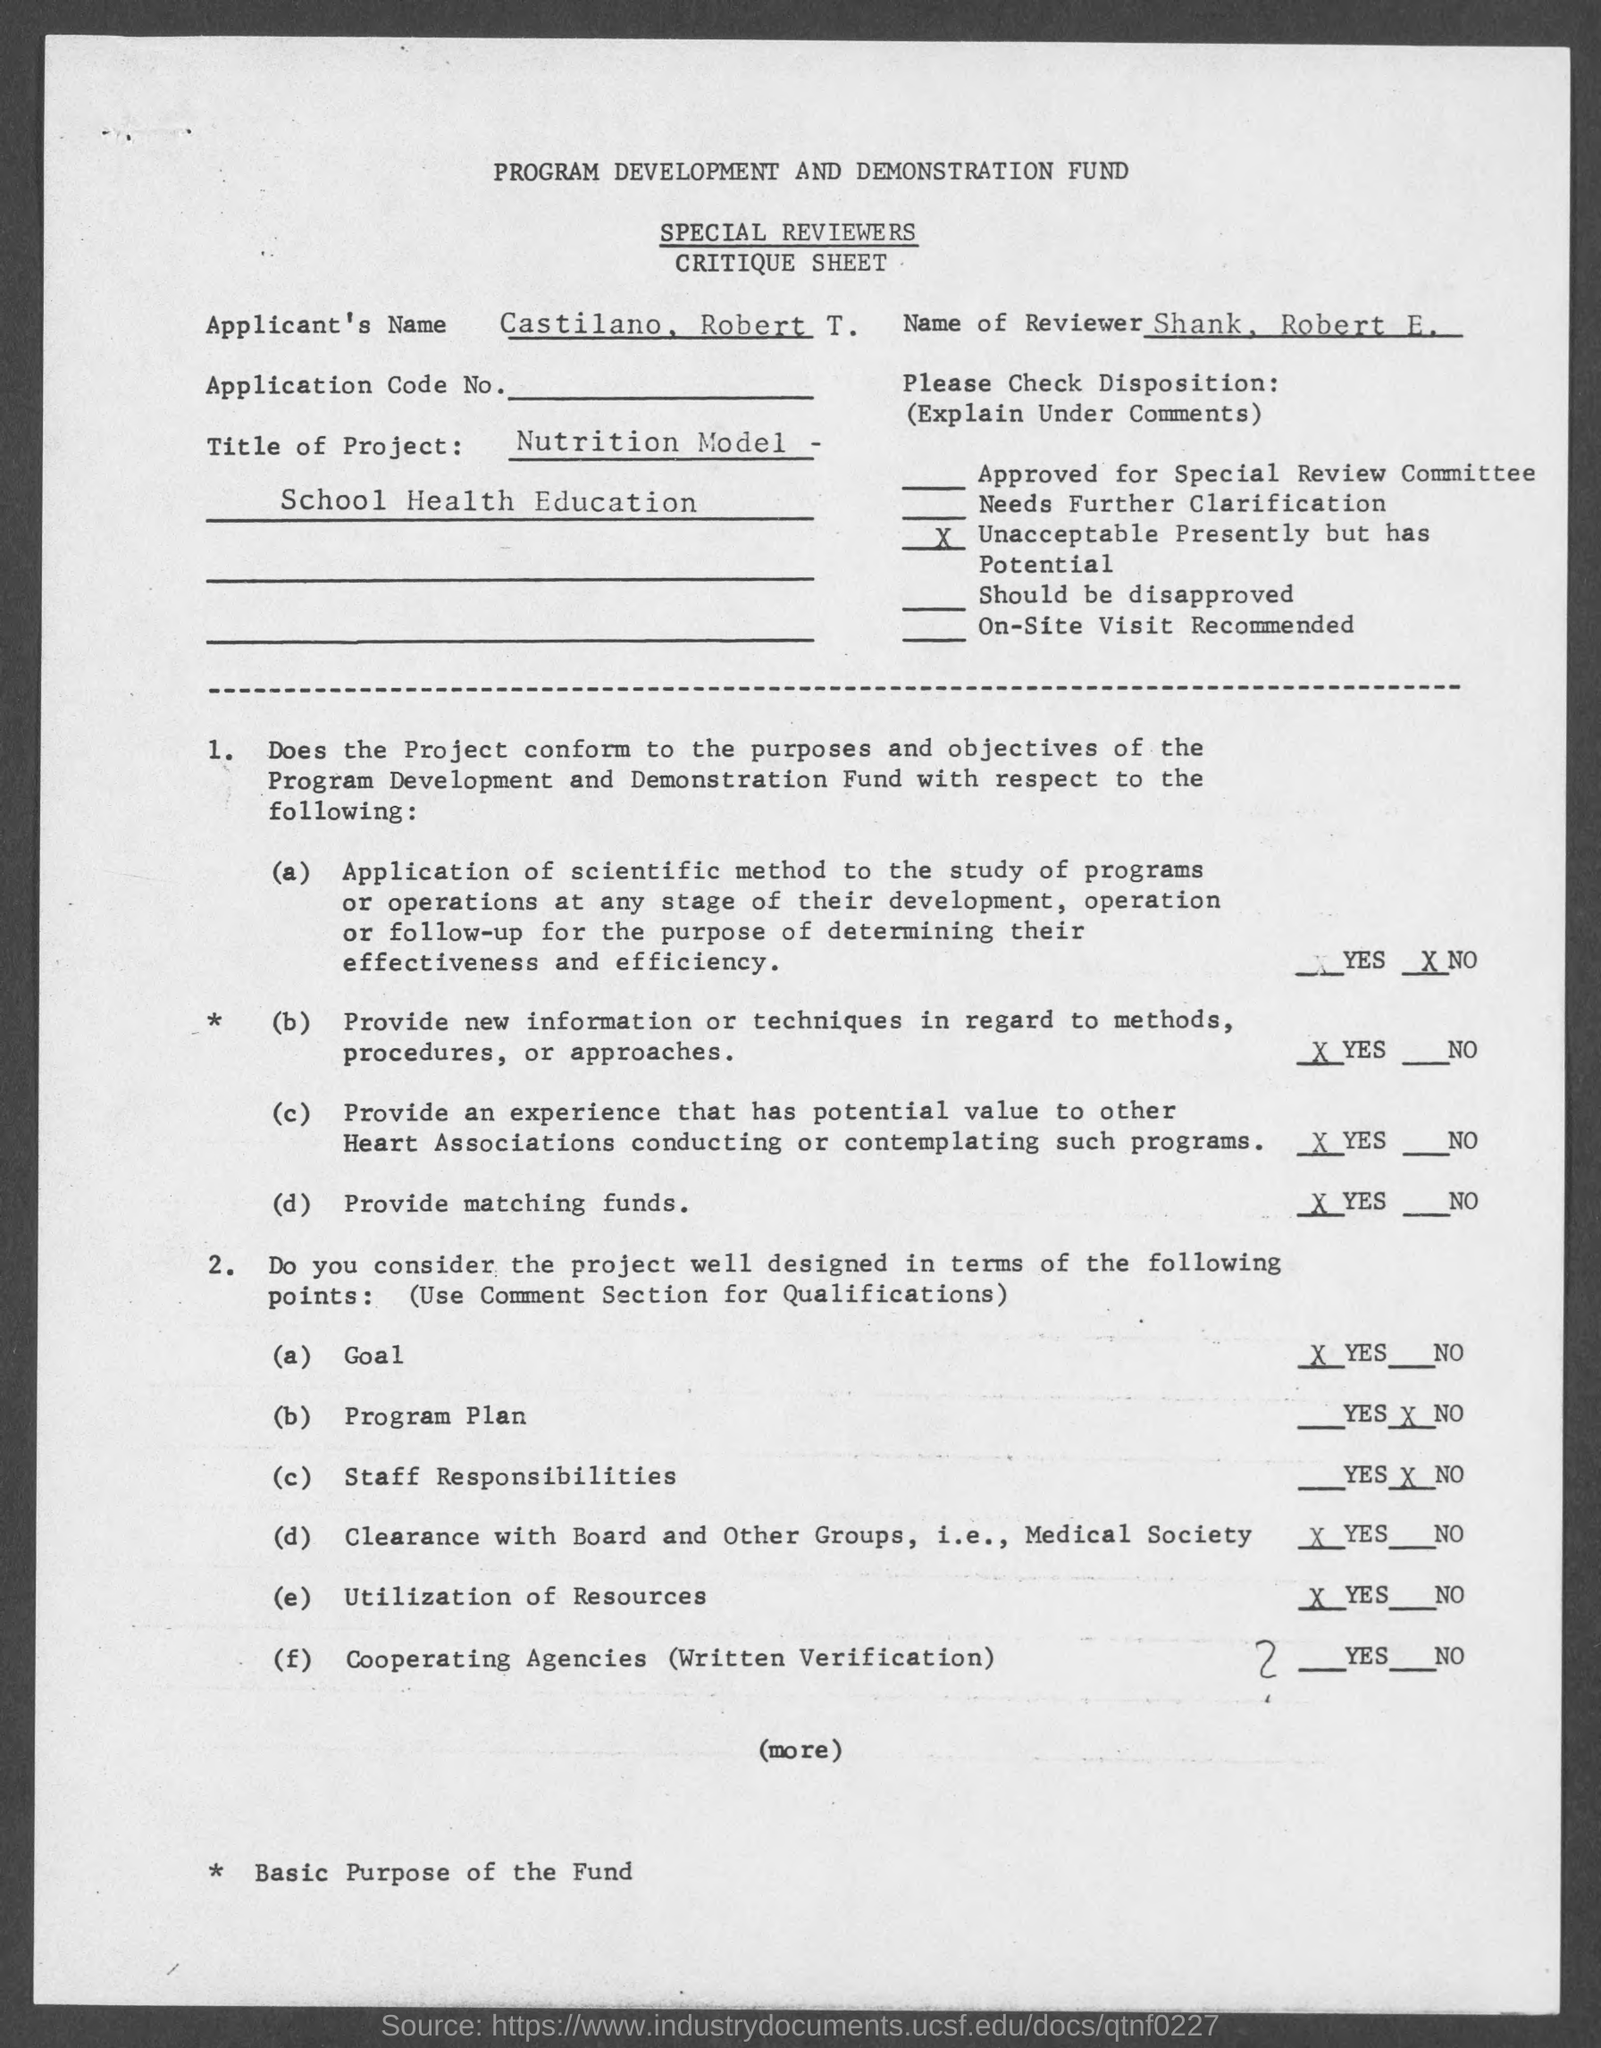Give some essential details in this illustration. The name of the applicant is Castilano, Robert T. The name of the reviewer is Shank, Robert E. 